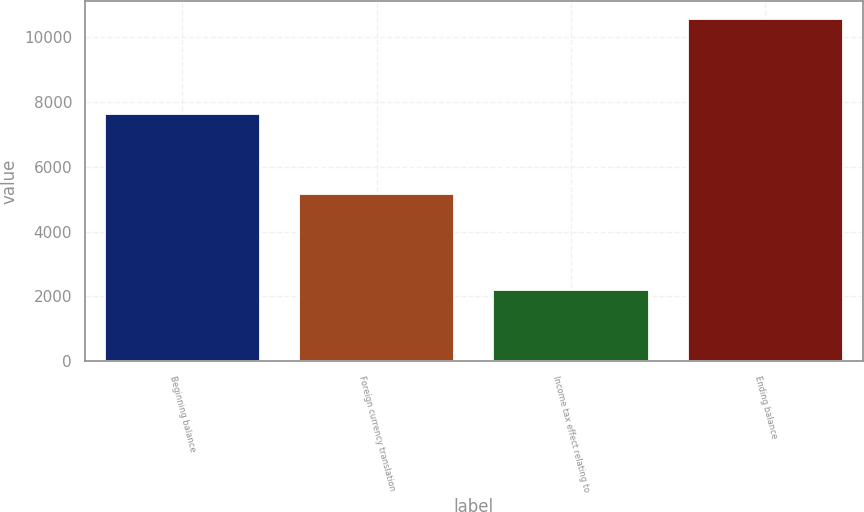Convert chart. <chart><loc_0><loc_0><loc_500><loc_500><bar_chart><fcel>Beginning balance<fcel>Foreign currency translation<fcel>Income tax effect relating to<fcel>Ending balance<nl><fcel>7632<fcel>5156<fcel>2208<fcel>10580<nl></chart> 